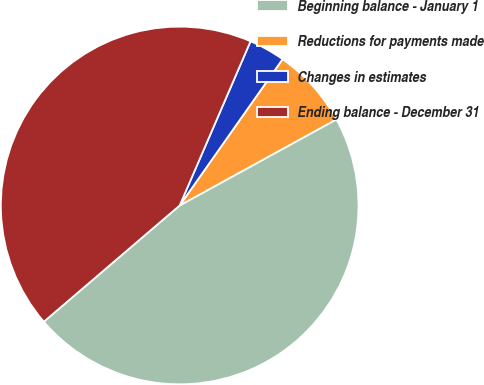Convert chart to OTSL. <chart><loc_0><loc_0><loc_500><loc_500><pie_chart><fcel>Beginning balance - January 1<fcel>Reductions for payments made<fcel>Changes in estimates<fcel>Ending balance - December 31<nl><fcel>46.73%<fcel>7.25%<fcel>3.27%<fcel>42.75%<nl></chart> 